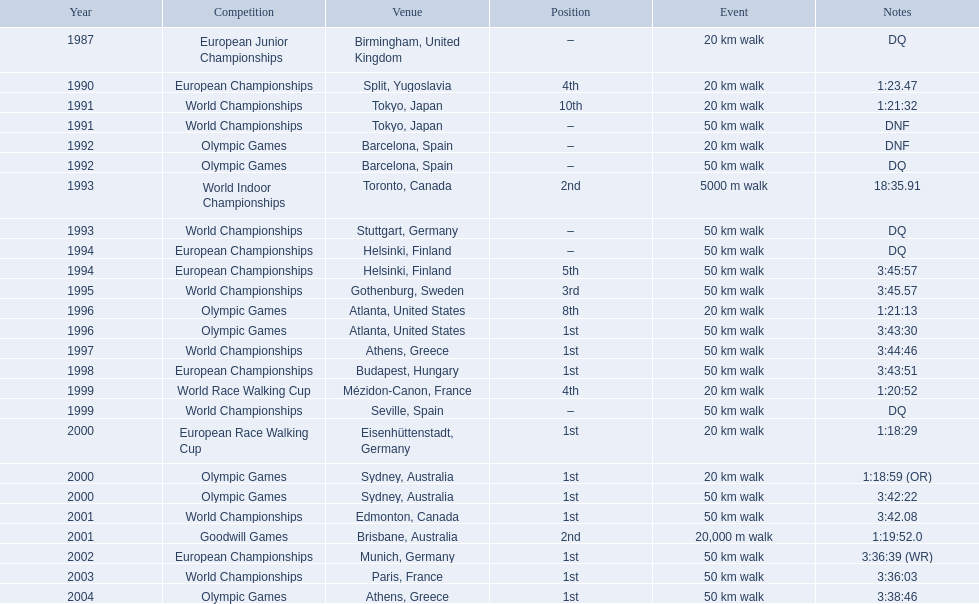What was robert korzeniowski's placement in 1990? 4th. In the 1993 world indoor championships, what was robert korzeniowski's rank? 2nd. How long did it take to complete the 50km walk during the 2004 olympic games? 3:38:46. 